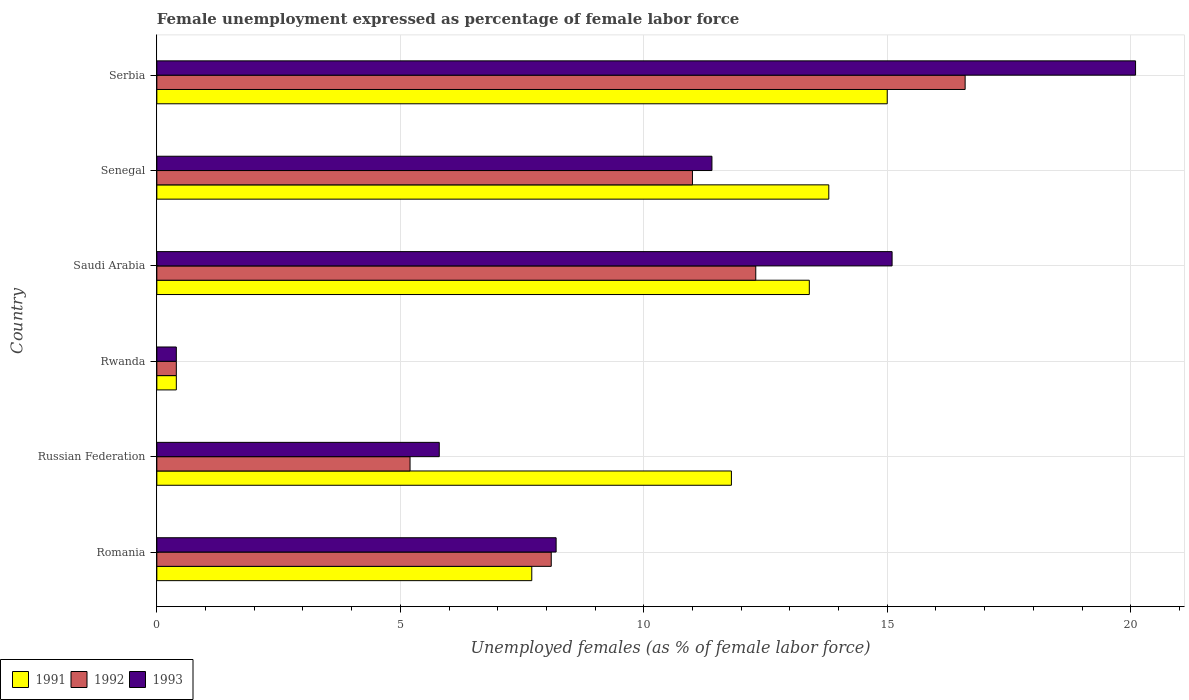Are the number of bars on each tick of the Y-axis equal?
Your response must be concise. Yes. How many bars are there on the 5th tick from the bottom?
Provide a short and direct response. 3. What is the label of the 5th group of bars from the top?
Provide a short and direct response. Russian Federation. In how many cases, is the number of bars for a given country not equal to the number of legend labels?
Ensure brevity in your answer.  0. What is the unemployment in females in in 1992 in Russian Federation?
Provide a short and direct response. 5.2. Across all countries, what is the maximum unemployment in females in in 1993?
Ensure brevity in your answer.  20.1. Across all countries, what is the minimum unemployment in females in in 1992?
Ensure brevity in your answer.  0.4. In which country was the unemployment in females in in 1991 maximum?
Provide a short and direct response. Serbia. In which country was the unemployment in females in in 1993 minimum?
Offer a terse response. Rwanda. What is the total unemployment in females in in 1992 in the graph?
Provide a succinct answer. 53.6. What is the difference between the unemployment in females in in 1992 in Romania and that in Senegal?
Offer a terse response. -2.9. What is the difference between the unemployment in females in in 1991 in Rwanda and the unemployment in females in in 1992 in Serbia?
Keep it short and to the point. -16.2. What is the average unemployment in females in in 1993 per country?
Ensure brevity in your answer.  10.17. What is the difference between the unemployment in females in in 1991 and unemployment in females in in 1993 in Romania?
Provide a succinct answer. -0.5. What is the ratio of the unemployment in females in in 1991 in Rwanda to that in Saudi Arabia?
Keep it short and to the point. 0.03. Is the unemployment in females in in 1991 in Romania less than that in Saudi Arabia?
Offer a very short reply. Yes. What is the difference between the highest and the second highest unemployment in females in in 1992?
Your response must be concise. 4.3. What is the difference between the highest and the lowest unemployment in females in in 1991?
Offer a very short reply. 14.6. In how many countries, is the unemployment in females in in 1992 greater than the average unemployment in females in in 1992 taken over all countries?
Provide a succinct answer. 3. Is it the case that in every country, the sum of the unemployment in females in in 1993 and unemployment in females in in 1991 is greater than the unemployment in females in in 1992?
Ensure brevity in your answer.  Yes. Are the values on the major ticks of X-axis written in scientific E-notation?
Give a very brief answer. No. Where does the legend appear in the graph?
Your answer should be compact. Bottom left. What is the title of the graph?
Keep it short and to the point. Female unemployment expressed as percentage of female labor force. What is the label or title of the X-axis?
Your answer should be compact. Unemployed females (as % of female labor force). What is the Unemployed females (as % of female labor force) of 1991 in Romania?
Offer a very short reply. 7.7. What is the Unemployed females (as % of female labor force) of 1992 in Romania?
Offer a terse response. 8.1. What is the Unemployed females (as % of female labor force) in 1993 in Romania?
Offer a very short reply. 8.2. What is the Unemployed females (as % of female labor force) in 1991 in Russian Federation?
Give a very brief answer. 11.8. What is the Unemployed females (as % of female labor force) of 1992 in Russian Federation?
Offer a very short reply. 5.2. What is the Unemployed females (as % of female labor force) in 1993 in Russian Federation?
Your answer should be compact. 5.8. What is the Unemployed females (as % of female labor force) of 1991 in Rwanda?
Ensure brevity in your answer.  0.4. What is the Unemployed females (as % of female labor force) of 1992 in Rwanda?
Keep it short and to the point. 0.4. What is the Unemployed females (as % of female labor force) in 1993 in Rwanda?
Your response must be concise. 0.4. What is the Unemployed females (as % of female labor force) of 1991 in Saudi Arabia?
Ensure brevity in your answer.  13.4. What is the Unemployed females (as % of female labor force) in 1992 in Saudi Arabia?
Offer a terse response. 12.3. What is the Unemployed females (as % of female labor force) in 1993 in Saudi Arabia?
Provide a short and direct response. 15.1. What is the Unemployed females (as % of female labor force) in 1991 in Senegal?
Keep it short and to the point. 13.8. What is the Unemployed females (as % of female labor force) of 1992 in Senegal?
Your answer should be very brief. 11. What is the Unemployed females (as % of female labor force) in 1993 in Senegal?
Your response must be concise. 11.4. What is the Unemployed females (as % of female labor force) of 1992 in Serbia?
Your answer should be compact. 16.6. What is the Unemployed females (as % of female labor force) in 1993 in Serbia?
Provide a succinct answer. 20.1. Across all countries, what is the maximum Unemployed females (as % of female labor force) in 1992?
Your answer should be compact. 16.6. Across all countries, what is the maximum Unemployed females (as % of female labor force) in 1993?
Offer a terse response. 20.1. Across all countries, what is the minimum Unemployed females (as % of female labor force) in 1991?
Your answer should be compact. 0.4. Across all countries, what is the minimum Unemployed females (as % of female labor force) in 1992?
Give a very brief answer. 0.4. Across all countries, what is the minimum Unemployed females (as % of female labor force) of 1993?
Your response must be concise. 0.4. What is the total Unemployed females (as % of female labor force) in 1991 in the graph?
Offer a terse response. 62.1. What is the total Unemployed females (as % of female labor force) of 1992 in the graph?
Ensure brevity in your answer.  53.6. What is the difference between the Unemployed females (as % of female labor force) in 1993 in Romania and that in Russian Federation?
Provide a short and direct response. 2.4. What is the difference between the Unemployed females (as % of female labor force) in 1991 in Romania and that in Rwanda?
Your answer should be compact. 7.3. What is the difference between the Unemployed females (as % of female labor force) of 1992 in Romania and that in Rwanda?
Your response must be concise. 7.7. What is the difference between the Unemployed females (as % of female labor force) of 1991 in Romania and that in Saudi Arabia?
Give a very brief answer. -5.7. What is the difference between the Unemployed females (as % of female labor force) of 1992 in Romania and that in Saudi Arabia?
Your answer should be very brief. -4.2. What is the difference between the Unemployed females (as % of female labor force) of 1993 in Romania and that in Senegal?
Provide a succinct answer. -3.2. What is the difference between the Unemployed females (as % of female labor force) of 1993 in Romania and that in Serbia?
Keep it short and to the point. -11.9. What is the difference between the Unemployed females (as % of female labor force) in 1991 in Russian Federation and that in Saudi Arabia?
Ensure brevity in your answer.  -1.6. What is the difference between the Unemployed females (as % of female labor force) in 1992 in Russian Federation and that in Saudi Arabia?
Make the answer very short. -7.1. What is the difference between the Unemployed females (as % of female labor force) in 1993 in Russian Federation and that in Saudi Arabia?
Your answer should be compact. -9.3. What is the difference between the Unemployed females (as % of female labor force) in 1991 in Russian Federation and that in Senegal?
Your response must be concise. -2. What is the difference between the Unemployed females (as % of female labor force) of 1992 in Russian Federation and that in Senegal?
Offer a terse response. -5.8. What is the difference between the Unemployed females (as % of female labor force) in 1993 in Russian Federation and that in Senegal?
Your answer should be very brief. -5.6. What is the difference between the Unemployed females (as % of female labor force) in 1991 in Russian Federation and that in Serbia?
Make the answer very short. -3.2. What is the difference between the Unemployed females (as % of female labor force) in 1992 in Russian Federation and that in Serbia?
Your response must be concise. -11.4. What is the difference between the Unemployed females (as % of female labor force) in 1993 in Russian Federation and that in Serbia?
Your response must be concise. -14.3. What is the difference between the Unemployed females (as % of female labor force) in 1993 in Rwanda and that in Saudi Arabia?
Keep it short and to the point. -14.7. What is the difference between the Unemployed females (as % of female labor force) in 1991 in Rwanda and that in Senegal?
Your answer should be compact. -13.4. What is the difference between the Unemployed females (as % of female labor force) of 1993 in Rwanda and that in Senegal?
Your response must be concise. -11. What is the difference between the Unemployed females (as % of female labor force) of 1991 in Rwanda and that in Serbia?
Offer a very short reply. -14.6. What is the difference between the Unemployed females (as % of female labor force) of 1992 in Rwanda and that in Serbia?
Give a very brief answer. -16.2. What is the difference between the Unemployed females (as % of female labor force) of 1993 in Rwanda and that in Serbia?
Offer a terse response. -19.7. What is the difference between the Unemployed females (as % of female labor force) of 1991 in Romania and the Unemployed females (as % of female labor force) of 1992 in Russian Federation?
Offer a very short reply. 2.5. What is the difference between the Unemployed females (as % of female labor force) of 1992 in Romania and the Unemployed females (as % of female labor force) of 1993 in Russian Federation?
Offer a very short reply. 2.3. What is the difference between the Unemployed females (as % of female labor force) in 1992 in Romania and the Unemployed females (as % of female labor force) in 1993 in Rwanda?
Make the answer very short. 7.7. What is the difference between the Unemployed females (as % of female labor force) in 1991 in Romania and the Unemployed females (as % of female labor force) in 1992 in Saudi Arabia?
Make the answer very short. -4.6. What is the difference between the Unemployed females (as % of female labor force) in 1991 in Russian Federation and the Unemployed females (as % of female labor force) in 1992 in Rwanda?
Your answer should be very brief. 11.4. What is the difference between the Unemployed females (as % of female labor force) of 1991 in Russian Federation and the Unemployed females (as % of female labor force) of 1993 in Rwanda?
Ensure brevity in your answer.  11.4. What is the difference between the Unemployed females (as % of female labor force) in 1992 in Russian Federation and the Unemployed females (as % of female labor force) in 1993 in Rwanda?
Make the answer very short. 4.8. What is the difference between the Unemployed females (as % of female labor force) of 1991 in Russian Federation and the Unemployed females (as % of female labor force) of 1992 in Senegal?
Your answer should be compact. 0.8. What is the difference between the Unemployed females (as % of female labor force) in 1991 in Russian Federation and the Unemployed females (as % of female labor force) in 1993 in Serbia?
Ensure brevity in your answer.  -8.3. What is the difference between the Unemployed females (as % of female labor force) in 1992 in Russian Federation and the Unemployed females (as % of female labor force) in 1993 in Serbia?
Your answer should be compact. -14.9. What is the difference between the Unemployed females (as % of female labor force) in 1991 in Rwanda and the Unemployed females (as % of female labor force) in 1993 in Saudi Arabia?
Make the answer very short. -14.7. What is the difference between the Unemployed females (as % of female labor force) of 1992 in Rwanda and the Unemployed females (as % of female labor force) of 1993 in Saudi Arabia?
Offer a terse response. -14.7. What is the difference between the Unemployed females (as % of female labor force) of 1992 in Rwanda and the Unemployed females (as % of female labor force) of 1993 in Senegal?
Your answer should be compact. -11. What is the difference between the Unemployed females (as % of female labor force) in 1991 in Rwanda and the Unemployed females (as % of female labor force) in 1992 in Serbia?
Keep it short and to the point. -16.2. What is the difference between the Unemployed females (as % of female labor force) of 1991 in Rwanda and the Unemployed females (as % of female labor force) of 1993 in Serbia?
Give a very brief answer. -19.7. What is the difference between the Unemployed females (as % of female labor force) of 1992 in Rwanda and the Unemployed females (as % of female labor force) of 1993 in Serbia?
Offer a terse response. -19.7. What is the difference between the Unemployed females (as % of female labor force) in 1991 in Saudi Arabia and the Unemployed females (as % of female labor force) in 1993 in Senegal?
Offer a very short reply. 2. What is the difference between the Unemployed females (as % of female labor force) of 1992 in Saudi Arabia and the Unemployed females (as % of female labor force) of 1993 in Senegal?
Your response must be concise. 0.9. What is the difference between the Unemployed females (as % of female labor force) of 1991 in Saudi Arabia and the Unemployed females (as % of female labor force) of 1993 in Serbia?
Give a very brief answer. -6.7. What is the difference between the Unemployed females (as % of female labor force) of 1991 in Senegal and the Unemployed females (as % of female labor force) of 1992 in Serbia?
Give a very brief answer. -2.8. What is the difference between the Unemployed females (as % of female labor force) in 1991 in Senegal and the Unemployed females (as % of female labor force) in 1993 in Serbia?
Keep it short and to the point. -6.3. What is the average Unemployed females (as % of female labor force) in 1991 per country?
Keep it short and to the point. 10.35. What is the average Unemployed females (as % of female labor force) of 1992 per country?
Keep it short and to the point. 8.93. What is the average Unemployed females (as % of female labor force) in 1993 per country?
Keep it short and to the point. 10.17. What is the difference between the Unemployed females (as % of female labor force) of 1991 and Unemployed females (as % of female labor force) of 1993 in Romania?
Ensure brevity in your answer.  -0.5. What is the difference between the Unemployed females (as % of female labor force) in 1991 and Unemployed females (as % of female labor force) in 1993 in Russian Federation?
Your answer should be compact. 6. What is the difference between the Unemployed females (as % of female labor force) of 1992 and Unemployed females (as % of female labor force) of 1993 in Russian Federation?
Keep it short and to the point. -0.6. What is the difference between the Unemployed females (as % of female labor force) in 1991 and Unemployed females (as % of female labor force) in 1992 in Rwanda?
Give a very brief answer. 0. What is the difference between the Unemployed females (as % of female labor force) in 1991 and Unemployed females (as % of female labor force) in 1993 in Rwanda?
Provide a succinct answer. 0. What is the difference between the Unemployed females (as % of female labor force) in 1991 and Unemployed females (as % of female labor force) in 1992 in Saudi Arabia?
Keep it short and to the point. 1.1. What is the difference between the Unemployed females (as % of female labor force) in 1991 and Unemployed females (as % of female labor force) in 1993 in Saudi Arabia?
Your response must be concise. -1.7. What is the difference between the Unemployed females (as % of female labor force) in 1992 and Unemployed females (as % of female labor force) in 1993 in Saudi Arabia?
Provide a succinct answer. -2.8. What is the difference between the Unemployed females (as % of female labor force) of 1991 and Unemployed females (as % of female labor force) of 1992 in Senegal?
Keep it short and to the point. 2.8. What is the difference between the Unemployed females (as % of female labor force) of 1991 and Unemployed females (as % of female labor force) of 1993 in Senegal?
Your response must be concise. 2.4. What is the difference between the Unemployed females (as % of female labor force) in 1992 and Unemployed females (as % of female labor force) in 1993 in Senegal?
Provide a succinct answer. -0.4. What is the difference between the Unemployed females (as % of female labor force) of 1991 and Unemployed females (as % of female labor force) of 1992 in Serbia?
Give a very brief answer. -1.6. What is the difference between the Unemployed females (as % of female labor force) of 1992 and Unemployed females (as % of female labor force) of 1993 in Serbia?
Provide a succinct answer. -3.5. What is the ratio of the Unemployed females (as % of female labor force) in 1991 in Romania to that in Russian Federation?
Your response must be concise. 0.65. What is the ratio of the Unemployed females (as % of female labor force) of 1992 in Romania to that in Russian Federation?
Provide a succinct answer. 1.56. What is the ratio of the Unemployed females (as % of female labor force) in 1993 in Romania to that in Russian Federation?
Offer a very short reply. 1.41. What is the ratio of the Unemployed females (as % of female labor force) of 1991 in Romania to that in Rwanda?
Your answer should be compact. 19.25. What is the ratio of the Unemployed females (as % of female labor force) of 1992 in Romania to that in Rwanda?
Offer a very short reply. 20.25. What is the ratio of the Unemployed females (as % of female labor force) of 1993 in Romania to that in Rwanda?
Make the answer very short. 20.5. What is the ratio of the Unemployed females (as % of female labor force) in 1991 in Romania to that in Saudi Arabia?
Your answer should be very brief. 0.57. What is the ratio of the Unemployed females (as % of female labor force) of 1992 in Romania to that in Saudi Arabia?
Make the answer very short. 0.66. What is the ratio of the Unemployed females (as % of female labor force) of 1993 in Romania to that in Saudi Arabia?
Offer a terse response. 0.54. What is the ratio of the Unemployed females (as % of female labor force) in 1991 in Romania to that in Senegal?
Your response must be concise. 0.56. What is the ratio of the Unemployed females (as % of female labor force) of 1992 in Romania to that in Senegal?
Provide a short and direct response. 0.74. What is the ratio of the Unemployed females (as % of female labor force) of 1993 in Romania to that in Senegal?
Offer a terse response. 0.72. What is the ratio of the Unemployed females (as % of female labor force) in 1991 in Romania to that in Serbia?
Make the answer very short. 0.51. What is the ratio of the Unemployed females (as % of female labor force) in 1992 in Romania to that in Serbia?
Make the answer very short. 0.49. What is the ratio of the Unemployed females (as % of female labor force) of 1993 in Romania to that in Serbia?
Offer a very short reply. 0.41. What is the ratio of the Unemployed females (as % of female labor force) in 1991 in Russian Federation to that in Rwanda?
Your answer should be very brief. 29.5. What is the ratio of the Unemployed females (as % of female labor force) of 1993 in Russian Federation to that in Rwanda?
Your answer should be very brief. 14.5. What is the ratio of the Unemployed females (as % of female labor force) in 1991 in Russian Federation to that in Saudi Arabia?
Provide a short and direct response. 0.88. What is the ratio of the Unemployed females (as % of female labor force) of 1992 in Russian Federation to that in Saudi Arabia?
Your response must be concise. 0.42. What is the ratio of the Unemployed females (as % of female labor force) of 1993 in Russian Federation to that in Saudi Arabia?
Give a very brief answer. 0.38. What is the ratio of the Unemployed females (as % of female labor force) in 1991 in Russian Federation to that in Senegal?
Ensure brevity in your answer.  0.86. What is the ratio of the Unemployed females (as % of female labor force) of 1992 in Russian Federation to that in Senegal?
Ensure brevity in your answer.  0.47. What is the ratio of the Unemployed females (as % of female labor force) of 1993 in Russian Federation to that in Senegal?
Provide a short and direct response. 0.51. What is the ratio of the Unemployed females (as % of female labor force) of 1991 in Russian Federation to that in Serbia?
Your answer should be very brief. 0.79. What is the ratio of the Unemployed females (as % of female labor force) in 1992 in Russian Federation to that in Serbia?
Offer a terse response. 0.31. What is the ratio of the Unemployed females (as % of female labor force) of 1993 in Russian Federation to that in Serbia?
Your answer should be very brief. 0.29. What is the ratio of the Unemployed females (as % of female labor force) of 1991 in Rwanda to that in Saudi Arabia?
Offer a terse response. 0.03. What is the ratio of the Unemployed females (as % of female labor force) of 1992 in Rwanda to that in Saudi Arabia?
Your answer should be compact. 0.03. What is the ratio of the Unemployed females (as % of female labor force) of 1993 in Rwanda to that in Saudi Arabia?
Make the answer very short. 0.03. What is the ratio of the Unemployed females (as % of female labor force) in 1991 in Rwanda to that in Senegal?
Your answer should be compact. 0.03. What is the ratio of the Unemployed females (as % of female labor force) of 1992 in Rwanda to that in Senegal?
Your answer should be compact. 0.04. What is the ratio of the Unemployed females (as % of female labor force) in 1993 in Rwanda to that in Senegal?
Offer a very short reply. 0.04. What is the ratio of the Unemployed females (as % of female labor force) of 1991 in Rwanda to that in Serbia?
Provide a short and direct response. 0.03. What is the ratio of the Unemployed females (as % of female labor force) of 1992 in Rwanda to that in Serbia?
Give a very brief answer. 0.02. What is the ratio of the Unemployed females (as % of female labor force) of 1993 in Rwanda to that in Serbia?
Ensure brevity in your answer.  0.02. What is the ratio of the Unemployed females (as % of female labor force) of 1991 in Saudi Arabia to that in Senegal?
Provide a succinct answer. 0.97. What is the ratio of the Unemployed females (as % of female labor force) of 1992 in Saudi Arabia to that in Senegal?
Your answer should be compact. 1.12. What is the ratio of the Unemployed females (as % of female labor force) in 1993 in Saudi Arabia to that in Senegal?
Offer a terse response. 1.32. What is the ratio of the Unemployed females (as % of female labor force) of 1991 in Saudi Arabia to that in Serbia?
Your response must be concise. 0.89. What is the ratio of the Unemployed females (as % of female labor force) of 1992 in Saudi Arabia to that in Serbia?
Provide a short and direct response. 0.74. What is the ratio of the Unemployed females (as % of female labor force) of 1993 in Saudi Arabia to that in Serbia?
Your answer should be compact. 0.75. What is the ratio of the Unemployed females (as % of female labor force) in 1991 in Senegal to that in Serbia?
Ensure brevity in your answer.  0.92. What is the ratio of the Unemployed females (as % of female labor force) in 1992 in Senegal to that in Serbia?
Your response must be concise. 0.66. What is the ratio of the Unemployed females (as % of female labor force) in 1993 in Senegal to that in Serbia?
Offer a terse response. 0.57. What is the difference between the highest and the second highest Unemployed females (as % of female labor force) of 1991?
Keep it short and to the point. 1.2. What is the difference between the highest and the lowest Unemployed females (as % of female labor force) of 1992?
Make the answer very short. 16.2. 